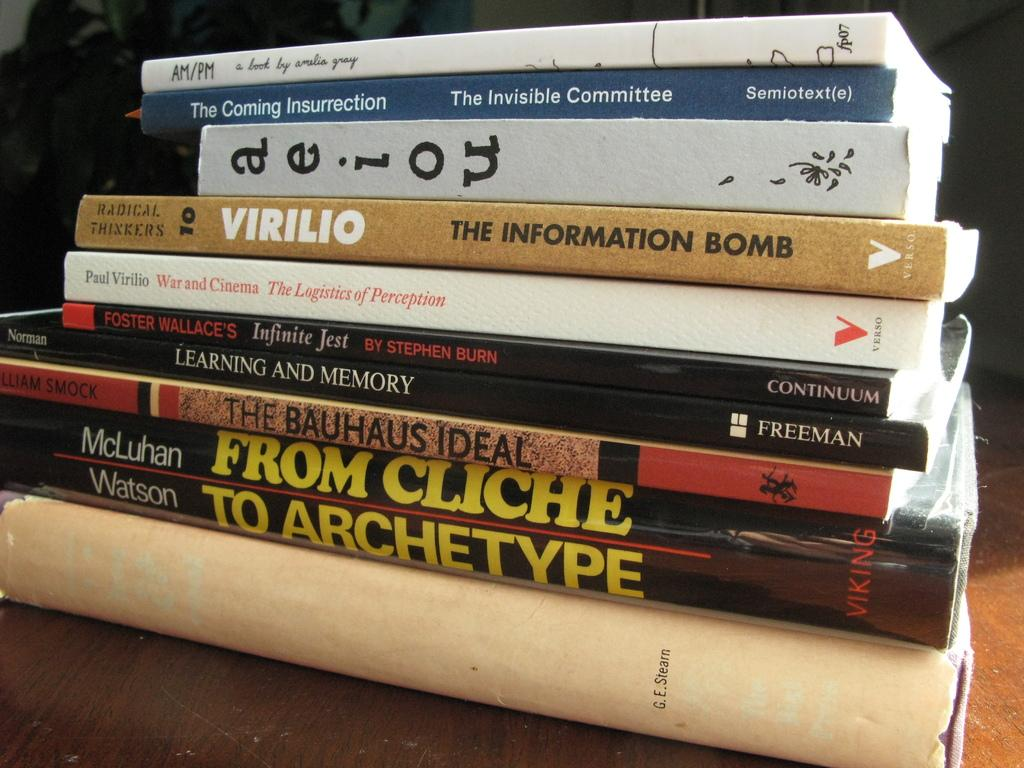<image>
Present a compact description of the photo's key features. A book titled The Coming Insurrection is in a stack of books with other books. 